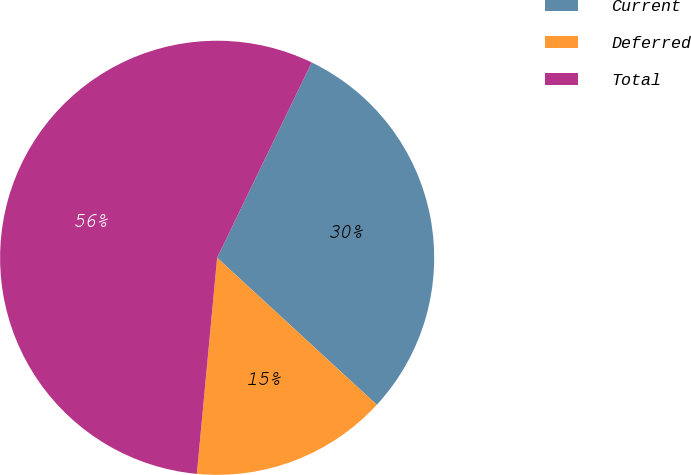<chart> <loc_0><loc_0><loc_500><loc_500><pie_chart><fcel>Current<fcel>Deferred<fcel>Total<nl><fcel>29.67%<fcel>14.65%<fcel>55.69%<nl></chart> 